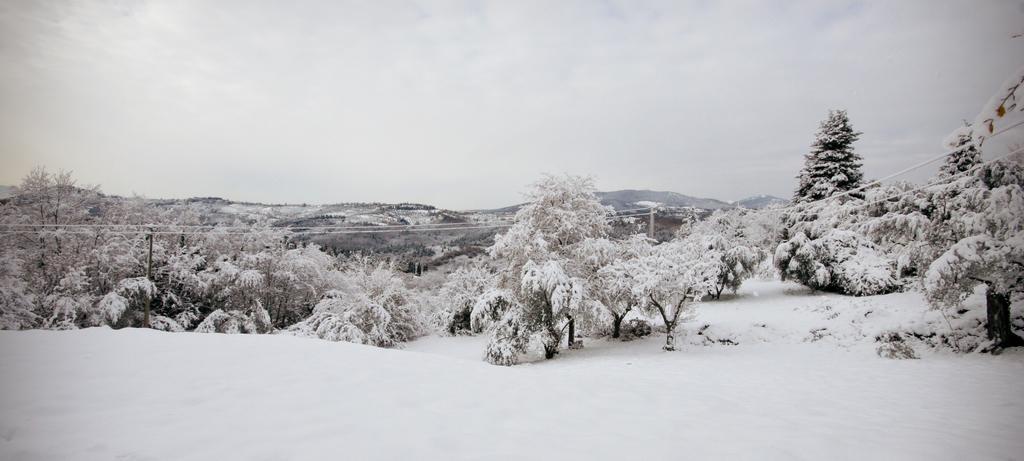Please provide a concise description of this image. This is an outside view. At the bottom, I can see the snow. In the middle of the image there are many trees covered with the snow. In the background there are hills. At the top of the image I can see the sky. 